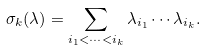<formula> <loc_0><loc_0><loc_500><loc_500>\sigma _ { k } ( \lambda ) = \sum _ { i _ { 1 } < \cdots < i _ { k } } \lambda _ { i _ { 1 } } \cdots \lambda _ { i _ { k } } .</formula> 